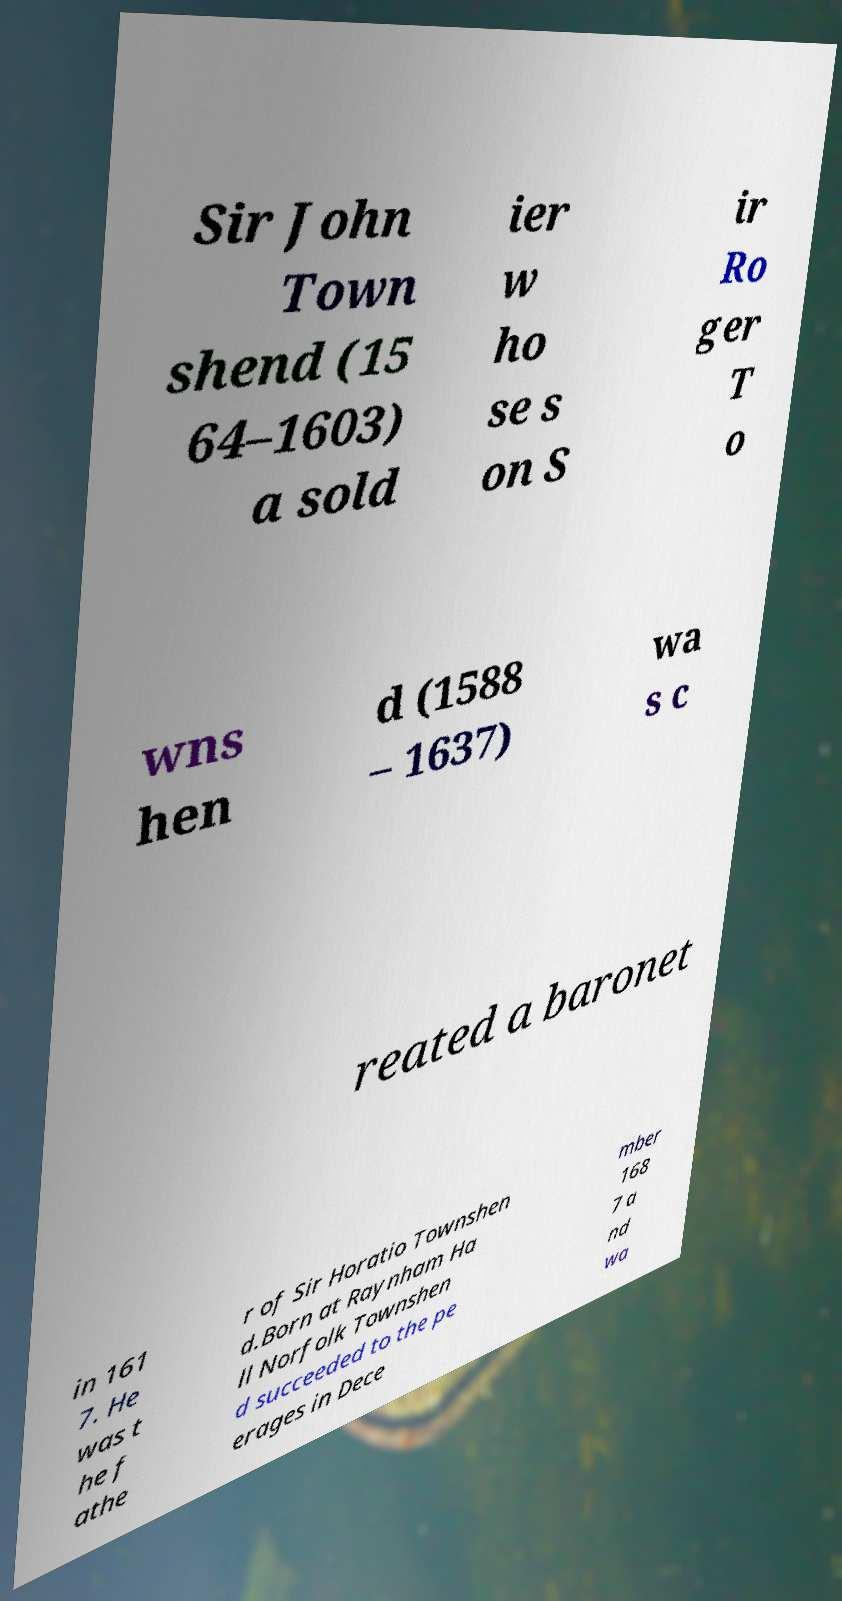What messages or text are displayed in this image? I need them in a readable, typed format. Sir John Town shend (15 64–1603) a sold ier w ho se s on S ir Ro ger T o wns hen d (1588 – 1637) wa s c reated a baronet in 161 7. He was t he f athe r of Sir Horatio Townshen d.Born at Raynham Ha ll Norfolk Townshen d succeeded to the pe erages in Dece mber 168 7 a nd wa 